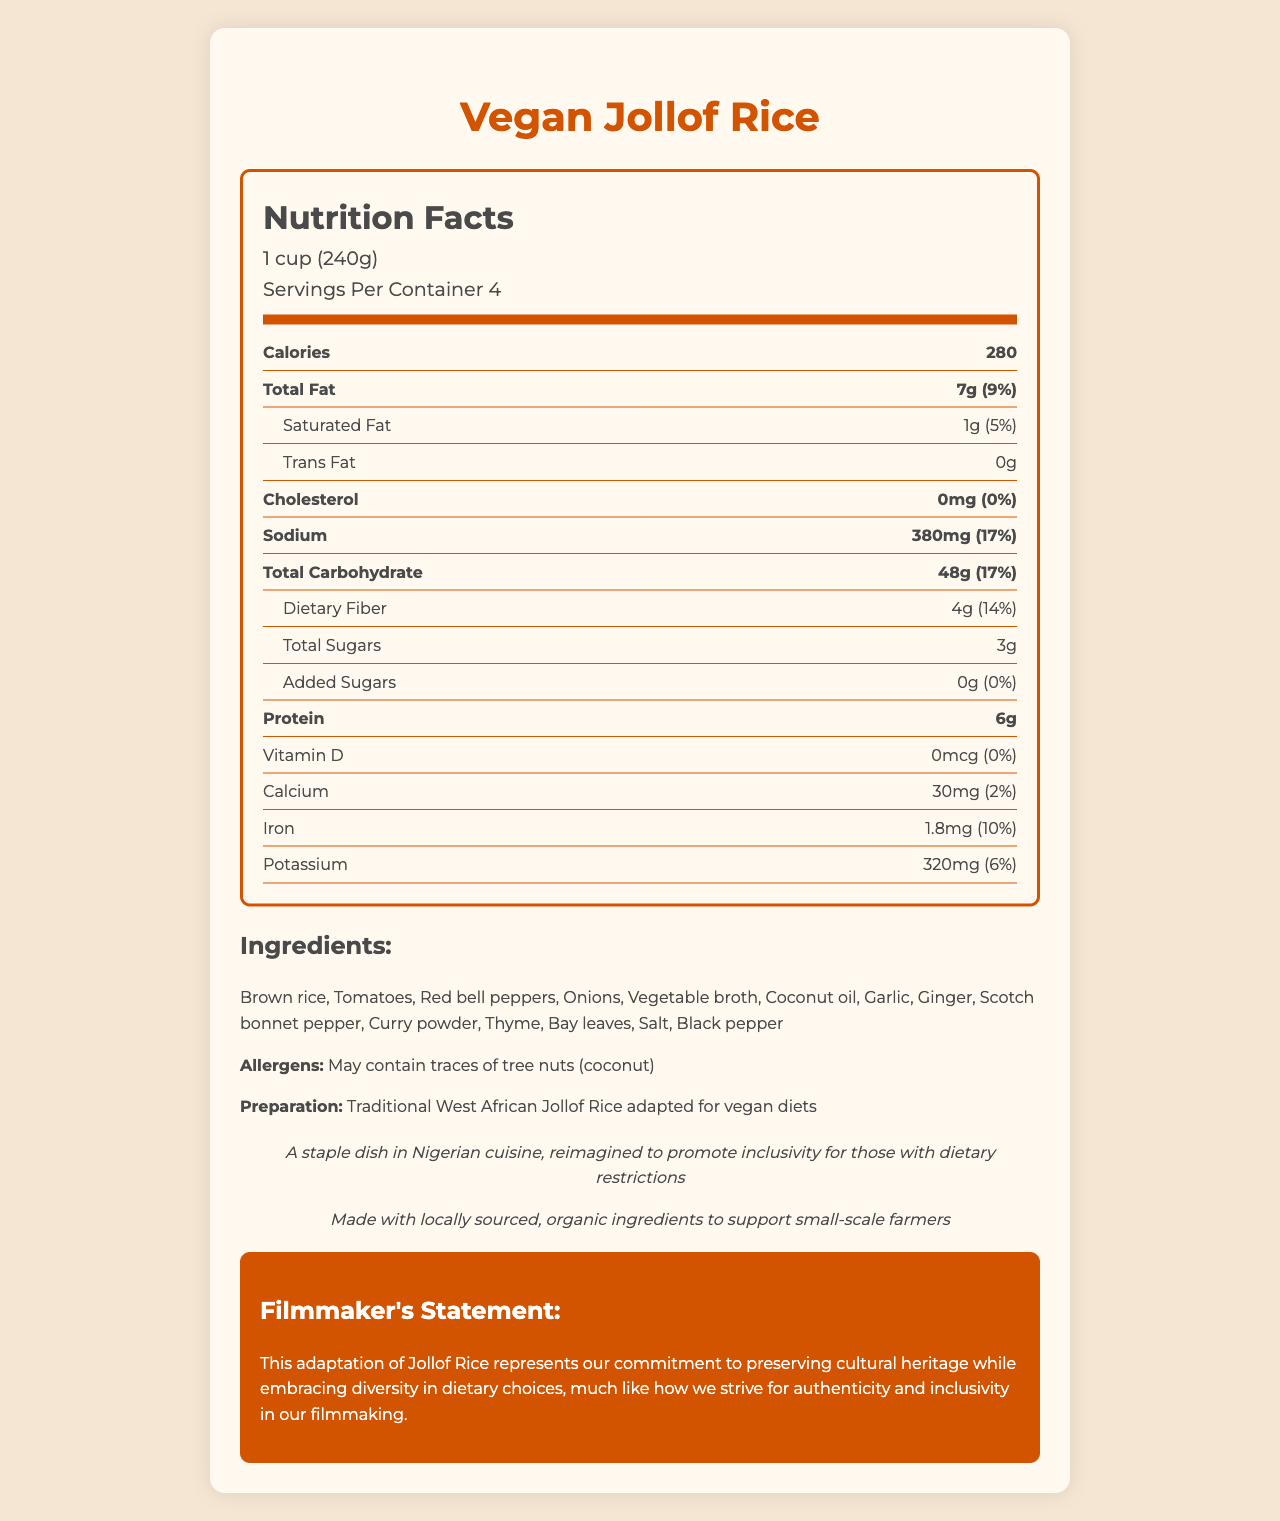what is the serving size? The serving size is explicitly mentioned at the beginning of the nutrition facts section.
Answer: 1 cup (240g) how many calories are in one serving of Vegan Jollof Rice? The calories per serving are given in a prominent part of the nutrition facts section.
Answer: 280 what is the total fat content per serving? The total fat content per serving is listed under the nutrition facts section, next to the calorie information.
Answer: 7g what is the percentage of daily value for sodium? The daily value percentage for sodium is provided next to the sodium content.
Answer: 17% how much protein does one serving contain? The protein content per serving is listed in the nutrition facts section under the total carbohydrate information.
Answer: 6g how much dietary fiber does one serving provide? The dietary fiber content per serving is included within the total carbohydrate section of the nutrition facts.
Answer: 4g identify one of the main ingredients of Vegan Jollof Rice. The ingredients list mentions brown rice as the first ingredient.
Answer: Brown rice of the following fats, which is present in Vegan Jollof Rice: A. Saturated Fat B. Trans Fat C. Monounsaturated Fat D. Polyunsaturated Fat According to the nutrition facts, Vegan Jollof Rice contains 1g of saturated fat and 0g of trans fat. Monounsaturated and polyunsaturated fats are not mentioned.
Answer: A which vitamin is Vegan Jollof Rice lacking in? 1. Vitamin A 2. Vitamin C 3. Vitamin D 4. Vitamin B12 The nutrition facts show that the Vitamin D content is 0mcg with a daily value of 0%.
Answer: 3 does Vegan Jollof Rice contain any cholesterol? The nutrition facts label indicates that the cholesterol content is 0mg, with a daily value of 0%.
Answer: No what does the sustainability note emphasize about the ingredients? The sustainability note mentions that the ingredients are locally sourced and organic, supporting small-scale farmers.
Answer: Made with locally sourced, organic ingredients to support small-scale farmers what does the filmmaker's statement indicate about the dish adaptation? The filmmaker's statement highlights the commitment to cultural heritage and inclusivity reflected in the dish.
Answer: The adaptation represents a commitment to preserving cultural heritage while embracing dietary inclusivity. how many servings are in one container of Vegan Jollof Rice? The number of servings per container is indicated as 4 in the nutrition facts section.
Answer: 4 what is the total carbohydrate content per serving? The nutrition facts section lists the total carbohydrate content per serving as 48g.
Answer: 48g what type of broth is used in Vegan Jollof Rice? The ingredients list specifies vegetable broth as one of the components.
Answer: Vegetable broth summarize the document in one sentence. The document provides a complete overview of the Vegan Jollof Rice's nutritional information, ingredients, and cultural notes, including a statement from the filmmaker about the relevance of this adaptation.
Answer: This is the nutrition facts label for Vegan Jollof Rice, highlighting its dietary details, ingredients, cultural significance, and the filmmaker’s statement on inclusivity and sustainability. what is the preparation method mentioned for Vegan Jollof Rice? The preparation method is noted under the preparation section, stating it is a traditional West African dish adapted for vegan diets.
Answer: Traditional West African Jollof Rice adapted for vegan diets what is the daily value percentage of calcium? The nutrition facts label lists the daily value percentage for calcium as 2%.
Answer: 2% is the scotch bonnet pepper listed as an ingredient? The ingredients list explicitly includes scotch bonnet pepper.
Answer: Yes how much added sugar is in one serving? The nutrition facts mention that there are 0g of added sugars per serving.
Answer: 0g how is the inclusion message reflected in the filmmaking process? The document provides a statement from the filmmaker about inclusivity in dietary choices, but does not detail how this parallels the filmmaking process directly.
Answer: Not enough information 